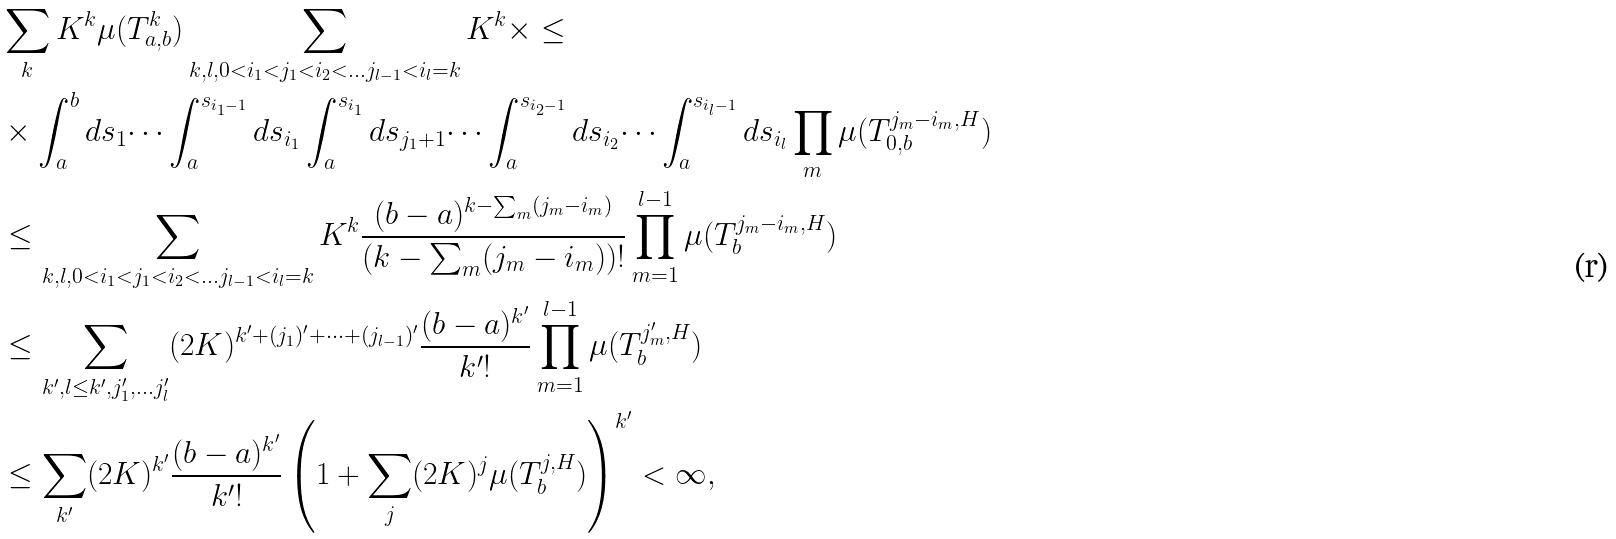<formula> <loc_0><loc_0><loc_500><loc_500>& \sum _ { k } K ^ { k } \mu ( T _ { a , b } ^ { k } ) \sum _ { k , l , 0 < i _ { 1 } < j _ { 1 } < i _ { 2 } < \dots j _ { l - 1 } < i _ { l } = k } K ^ { k } \times \leq \\ & \times \int _ { a } ^ { b } d s _ { 1 } \dots \int _ { a } ^ { s _ { i _ { 1 } - 1 } } d s _ { i _ { 1 } } \int _ { a } ^ { s _ { i _ { 1 } } } d s _ { j _ { 1 } + 1 } \dots \int _ { a } ^ { s _ { i _ { 2 } - 1 } } d s _ { i _ { 2 } } \dots \int _ { a } ^ { s _ { i _ { l } - 1 } } d s _ { i _ { l } } \prod _ { m } \mu ( T _ { 0 , b } ^ { j _ { m } - i _ { m } , H } ) \\ & \leq \sum _ { k , l , 0 < i _ { 1 } < j _ { 1 } < i _ { 2 } < \dots j _ { l - 1 } < i _ { l } = k } K ^ { k } \frac { ( b - a ) ^ { k - \sum _ { m } ( j _ { m } - i _ { m } ) } } { ( k - \sum _ { m } ( j _ { m } - i _ { m } ) ) ! } \prod _ { m = 1 } ^ { l - 1 } \mu ( T _ { b } ^ { j _ { m } - i _ { m } , H } ) \\ & \leq \sum _ { k ^ { \prime } , l \leq k ^ { \prime } , j _ { 1 } ^ { \prime } , \dots j _ { l } ^ { \prime } } ( 2 K ) ^ { k ^ { \prime } + ( j _ { 1 } ) ^ { \prime } + \dots + ( j _ { l - 1 } ) ^ { \prime } } \frac { ( b - a ) ^ { k ^ { \prime } } } { k ^ { \prime } ! } \prod _ { m = 1 } ^ { l - 1 } \mu ( T _ { b } ^ { j ^ { \prime } _ { m } , H } ) \\ & \leq \sum _ { k ^ { \prime } } ( 2 K ) ^ { k ^ { \prime } } \frac { ( b - a ) ^ { k ^ { \prime } } } { k ^ { \prime } ! } \left ( 1 + \sum _ { j } ( 2 K ) ^ { j } \mu ( T _ { b } ^ { j , H } ) \right ) ^ { k ^ { \prime } } < \infty ,</formula> 